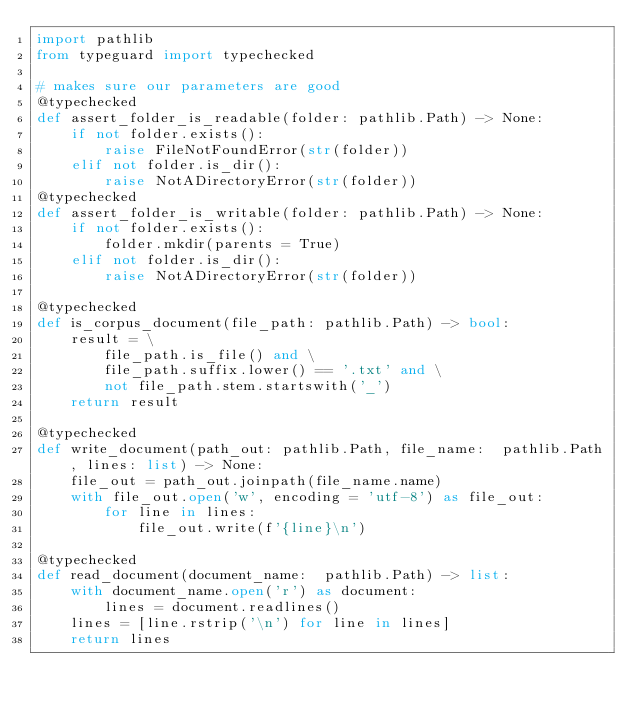<code> <loc_0><loc_0><loc_500><loc_500><_Python_>import pathlib
from typeguard import typechecked

# makes sure our parameters are good
@typechecked
def assert_folder_is_readable(folder: pathlib.Path) -> None:
    if not folder.exists():
        raise FileNotFoundError(str(folder))
    elif not folder.is_dir():
        raise NotADirectoryError(str(folder))
@typechecked
def assert_folder_is_writable(folder: pathlib.Path) -> None:
    if not folder.exists():
        folder.mkdir(parents = True)
    elif not folder.is_dir():
        raise NotADirectoryError(str(folder))

@typechecked
def is_corpus_document(file_path: pathlib.Path) -> bool:
    result = \
        file_path.is_file() and \
        file_path.suffix.lower() == '.txt' and \
        not file_path.stem.startswith('_')
    return result

@typechecked
def write_document(path_out: pathlib.Path, file_name:  pathlib.Path, lines: list) -> None:
    file_out = path_out.joinpath(file_name.name)
    with file_out.open('w', encoding = 'utf-8') as file_out:
        for line in lines:
            file_out.write(f'{line}\n')

@typechecked
def read_document(document_name:  pathlib.Path) -> list:
    with document_name.open('r') as document:
        lines = document.readlines()
    lines = [line.rstrip('\n') for line in lines]
    return lines
</code> 